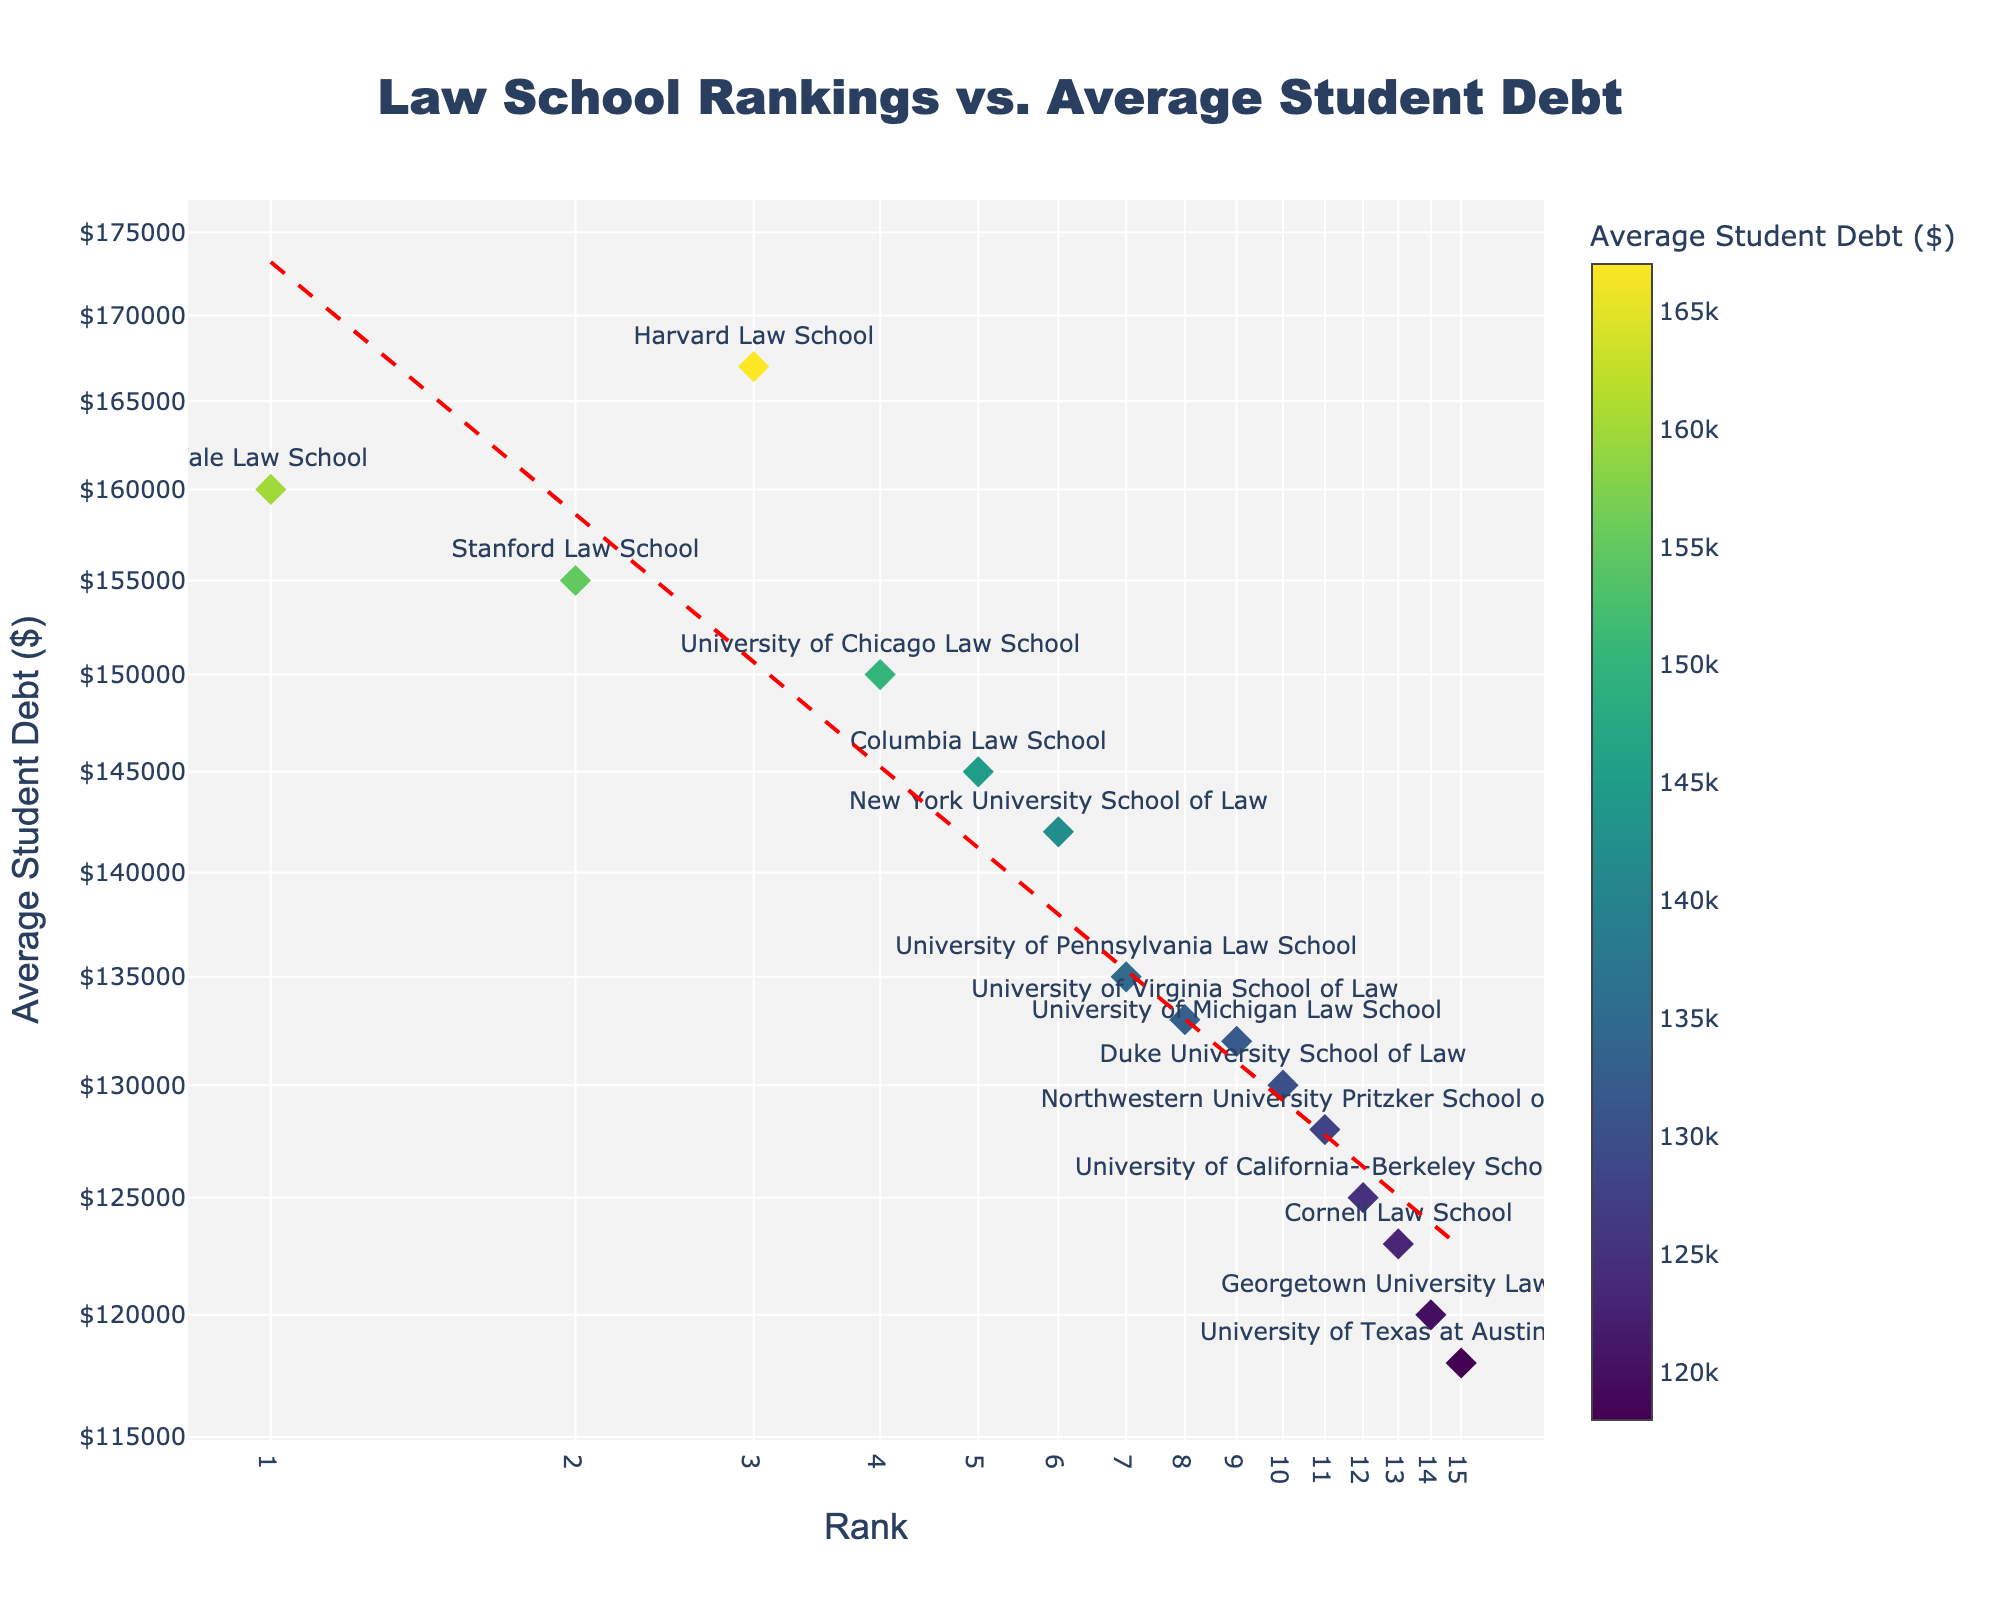what's the title of the figure? The title is located at the top center of the figure. It uses a larger font size than other texts.
Answer: Law School Rankings vs. Average Student Debt how many data points are shown in the scatter plot? Count each law school listed in the hover text as a single data point on the plot.
Answer: 15 which law school has the highest student debt? Look for the data point with the highest y-value, hover over the points to see the debt amounts, and find the corresponding school.
Answer: Harvard Law School what's the average student debt for law schools ranked in the top 5? Identify the y-values for ranks 1 through 5: Harvard (167000), Yale (160000), Stanford (155000), Chicago (150000), Columbia (145000). Calculate the average: (167000 + 160000 + 155000 + 150000 + 145000) / 5 = 155400.
Answer: $155,400 which law school has the lowest student debt, and what is the value? Look for the data point with the lowest y-value, hover over the points to see the debt amounts, and find the corresponding school.
Answer: University of Texas at Austin School of Law, $118,000 is there a general trend between rank and average student debt? Observe the trend line in red and notice how the student debt changes across different ranks.
Answer: As rank increases (worsens), debt generally decreases what’s the difference in average student debt between the highest-ranked and lowest-ranked schools? Identify the y-values for the highest-ranked (Yale, $160,000) and the lowest-ranked (University of Texas, $118,000). Calculate the difference: $160,000 - $118,000 = $42,000.
Answer: $42,000 which law school has a rank of 7 and what's its average student debt? Find the x-value of 7 on the x-axis, hover over the corresponding data point to see the school's name and debt amount.
Answer: University of Pennsylvania Law School, $135,000 what color represents the highest student debt and what does the color indicate? The color gradient scale (colorbar) on the right shows that colors towards the higher end represent higher debts.
Answer: Darker colors indicate higher student debt 